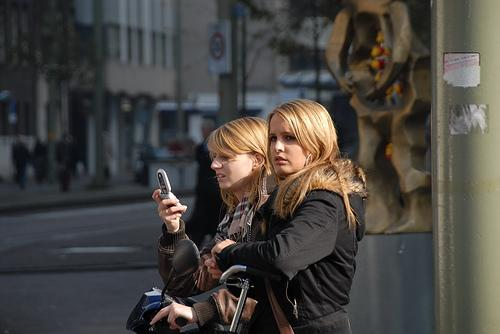The woman on the phone is using what item to move around? scooter 